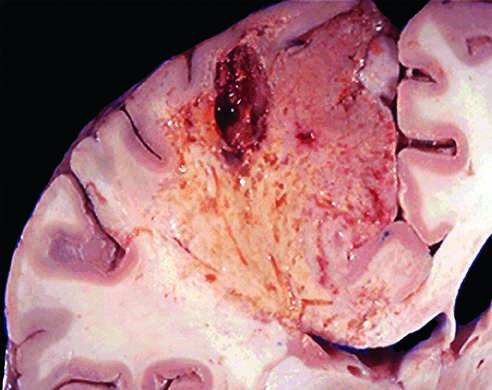does an infarct in the brain show dissolution of the tissue?
Answer the question using a single word or phrase. Yes 